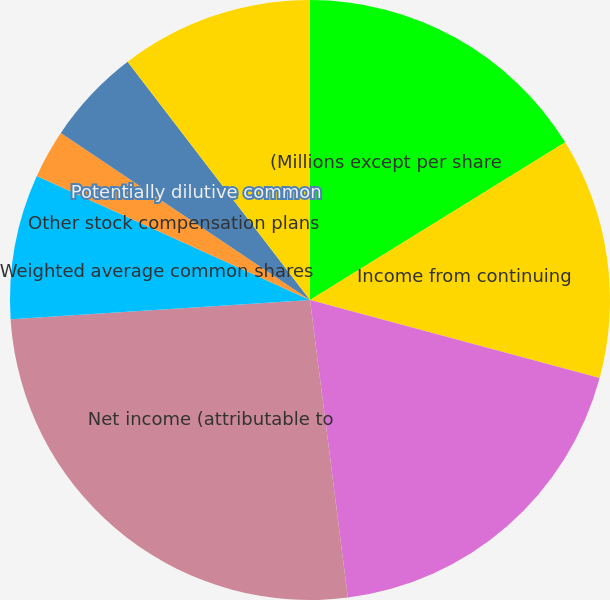<chart> <loc_0><loc_0><loc_500><loc_500><pie_chart><fcel>(Millions except per share<fcel>Income from continuing<fcel>Income from discontinued<fcel>Net income (attributable to<fcel>Weighted average common shares<fcel>Stock options<fcel>Other stock compensation plans<fcel>Potentially dilutive common<fcel>Adjusted weighted average<nl><fcel>16.19%<fcel>13.0%<fcel>18.79%<fcel>25.99%<fcel>7.8%<fcel>0.01%<fcel>2.61%<fcel>5.2%<fcel>10.4%<nl></chart> 